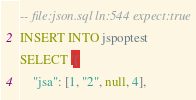Convert code to text. <code><loc_0><loc_0><loc_500><loc_500><_SQL_>-- file:json.sql ln:544 expect:true
INSERT INTO jspoptest
SELECT '{
	"jsa": [1, "2", null, 4],</code> 